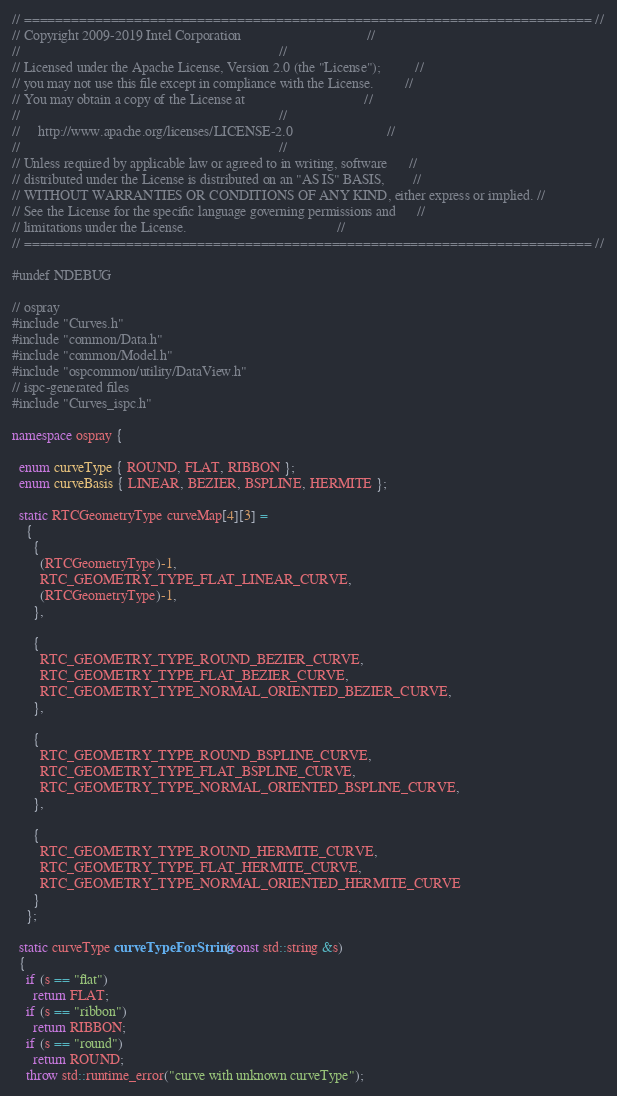Convert code to text. <code><loc_0><loc_0><loc_500><loc_500><_C++_>// ======================================================================== //
// Copyright 2009-2019 Intel Corporation                                    //
//                                                                          //
// Licensed under the Apache License, Version 2.0 (the "License");          //
// you may not use this file except in compliance with the License.         //
// You may obtain a copy of the License at                                  //
//                                                                          //
//     http://www.apache.org/licenses/LICENSE-2.0                           //
//                                                                          //
// Unless required by applicable law or agreed to in writing, software      //
// distributed under the License is distributed on an "AS IS" BASIS,        //
// WITHOUT WARRANTIES OR CONDITIONS OF ANY KIND, either express or implied. //
// See the License for the specific language governing permissions and      //
// limitations under the License.                                           //
// ======================================================================== //

#undef NDEBUG

// ospray
#include "Curves.h"
#include "common/Data.h"
#include "common/Model.h"
#include "ospcommon/utility/DataView.h"
// ispc-generated files
#include "Curves_ispc.h"

namespace ospray {

  enum curveType { ROUND, FLAT, RIBBON };
  enum curveBasis { LINEAR, BEZIER, BSPLINE, HERMITE };

  static RTCGeometryType curveMap[4][3] =
    {
      {
        (RTCGeometryType)-1,
        RTC_GEOMETRY_TYPE_FLAT_LINEAR_CURVE,
        (RTCGeometryType)-1,
      },

      {
        RTC_GEOMETRY_TYPE_ROUND_BEZIER_CURVE,
        RTC_GEOMETRY_TYPE_FLAT_BEZIER_CURVE,
        RTC_GEOMETRY_TYPE_NORMAL_ORIENTED_BEZIER_CURVE,
      },

      {
        RTC_GEOMETRY_TYPE_ROUND_BSPLINE_CURVE,
        RTC_GEOMETRY_TYPE_FLAT_BSPLINE_CURVE,
        RTC_GEOMETRY_TYPE_NORMAL_ORIENTED_BSPLINE_CURVE,
      },

      {
        RTC_GEOMETRY_TYPE_ROUND_HERMITE_CURVE,
        RTC_GEOMETRY_TYPE_FLAT_HERMITE_CURVE,
        RTC_GEOMETRY_TYPE_NORMAL_ORIENTED_HERMITE_CURVE
      }
    };

  static curveType curveTypeForString(const std::string &s)
  {
    if (s == "flat")
      return FLAT;
    if (s == "ribbon")
      return RIBBON;
    if (s == "round")
      return ROUND;
    throw std::runtime_error("curve with unknown curveType");</code> 